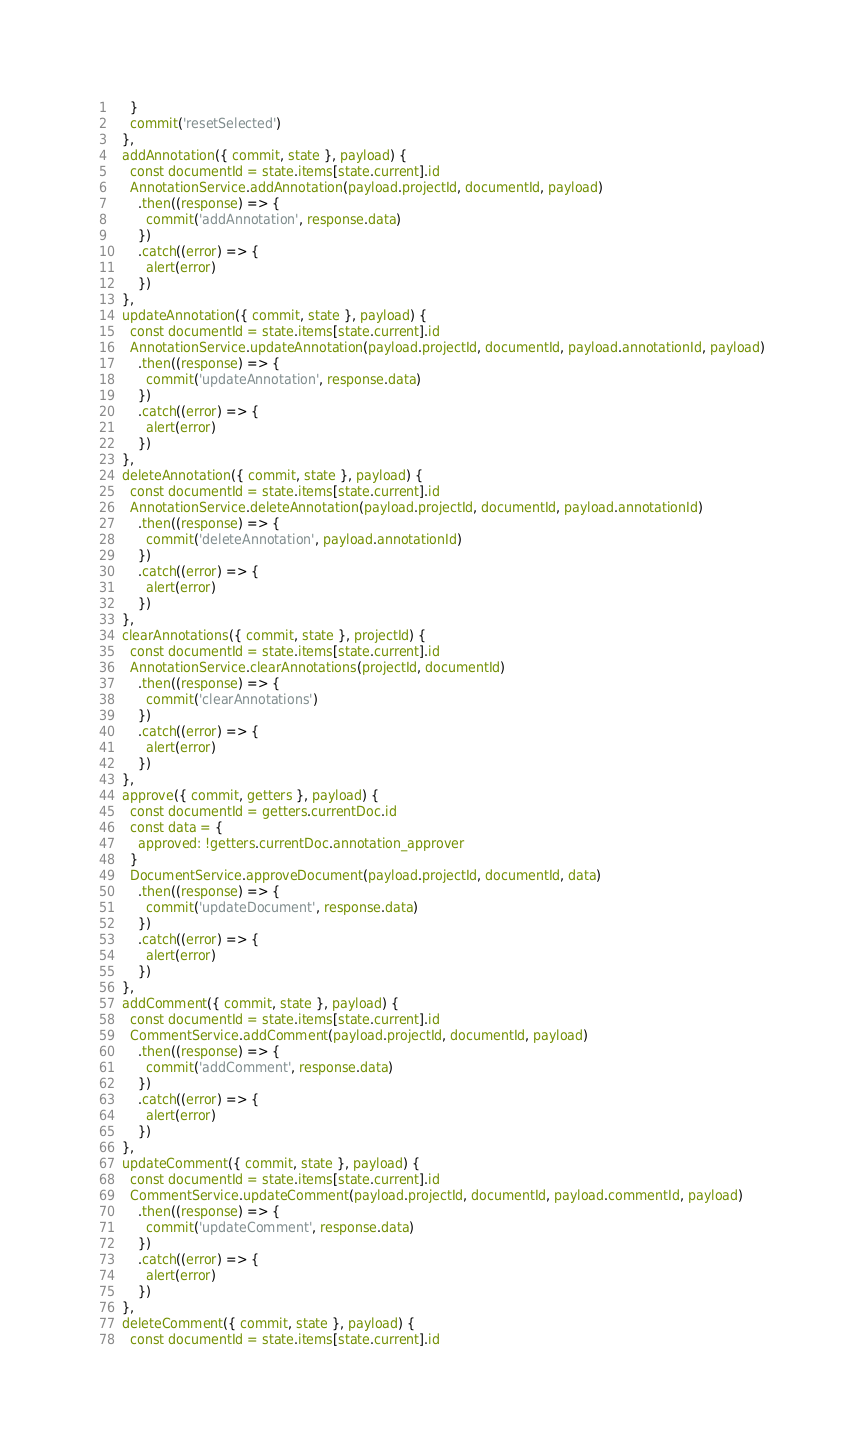<code> <loc_0><loc_0><loc_500><loc_500><_JavaScript_>    }
    commit('resetSelected')
  },
  addAnnotation({ commit, state }, payload) {
    const documentId = state.items[state.current].id
    AnnotationService.addAnnotation(payload.projectId, documentId, payload)
      .then((response) => {
        commit('addAnnotation', response.data)
      })
      .catch((error) => {
        alert(error)
      })
  },
  updateAnnotation({ commit, state }, payload) {
    const documentId = state.items[state.current].id
    AnnotationService.updateAnnotation(payload.projectId, documentId, payload.annotationId, payload)
      .then((response) => {
        commit('updateAnnotation', response.data)
      })
      .catch((error) => {
        alert(error)
      })
  },
  deleteAnnotation({ commit, state }, payload) {
    const documentId = state.items[state.current].id
    AnnotationService.deleteAnnotation(payload.projectId, documentId, payload.annotationId)
      .then((response) => {
        commit('deleteAnnotation', payload.annotationId)
      })
      .catch((error) => {
        alert(error)
      })
  },
  clearAnnotations({ commit, state }, projectId) {
    const documentId = state.items[state.current].id
    AnnotationService.clearAnnotations(projectId, documentId)
      .then((response) => {
        commit('clearAnnotations')
      })
      .catch((error) => {
        alert(error)
      })
  },
  approve({ commit, getters }, payload) {
    const documentId = getters.currentDoc.id
    const data = {
      approved: !getters.currentDoc.annotation_approver
    }
    DocumentService.approveDocument(payload.projectId, documentId, data)
      .then((response) => {
        commit('updateDocument', response.data)
      })
      .catch((error) => {
        alert(error)
      })
  },
  addComment({ commit, state }, payload) {
    const documentId = state.items[state.current].id
    CommentService.addComment(payload.projectId, documentId, payload)
      .then((response) => {
        commit('addComment', response.data)
      })
      .catch((error) => {
        alert(error)
      })
  },
  updateComment({ commit, state }, payload) {
    const documentId = state.items[state.current].id
    CommentService.updateComment(payload.projectId, documentId, payload.commentId, payload)
      .then((response) => {
        commit('updateComment', response.data)
      })
      .catch((error) => {
        alert(error)
      })
  },
  deleteComment({ commit, state }, payload) {
    const documentId = state.items[state.current].id</code> 